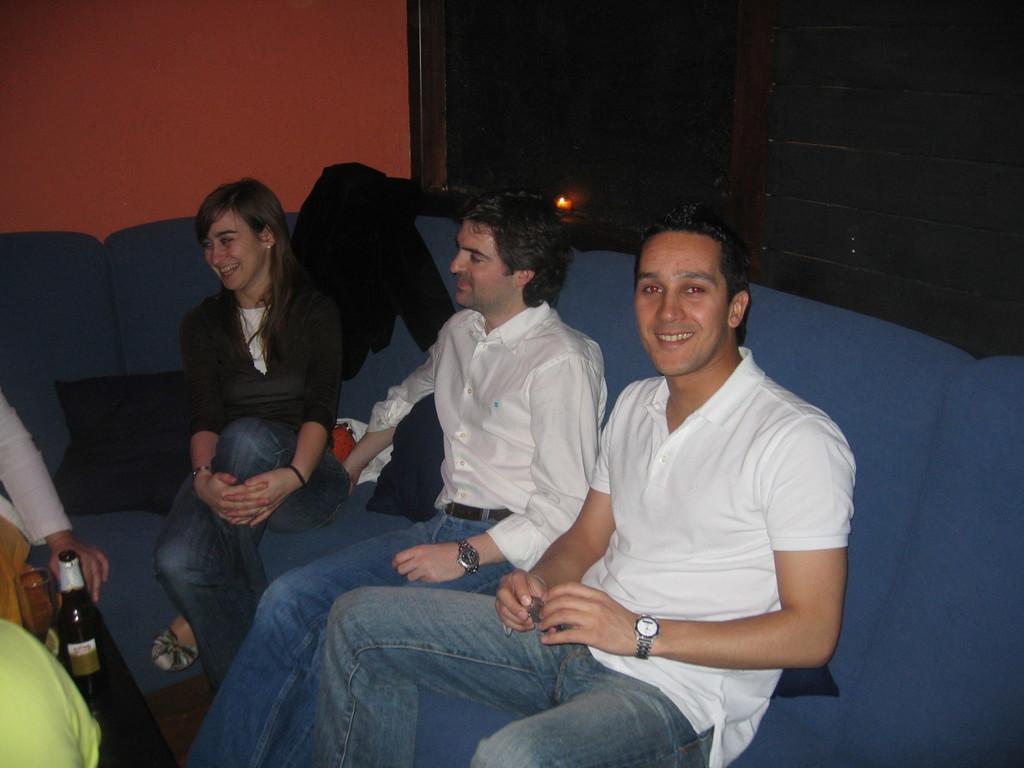How would you summarize this image in a sentence or two? This picture shows few people seated on the sofa and we see a human hand holding beer bottle and we see a glass and we see clothes on the back and we see smile on their faces. 